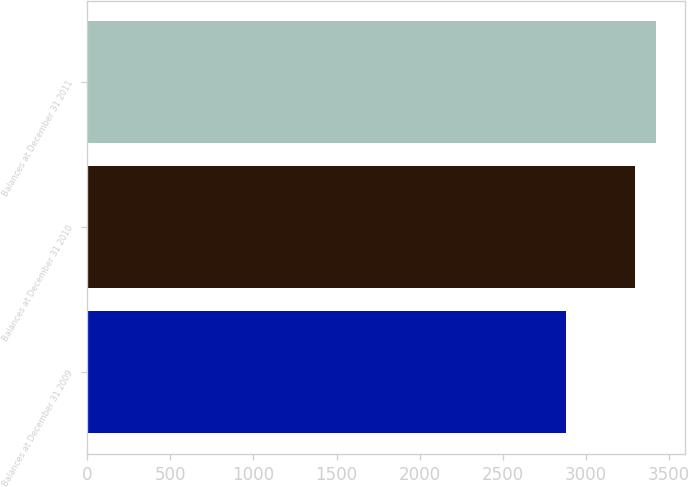<chart> <loc_0><loc_0><loc_500><loc_500><bar_chart><fcel>Balances at December 31 2009<fcel>Balances at December 31 2010<fcel>Balances at December 31 2011<nl><fcel>2882.2<fcel>3296.5<fcel>3420.7<nl></chart> 